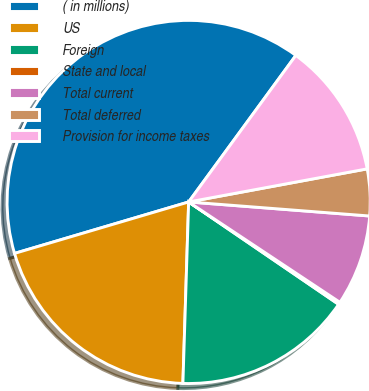Convert chart. <chart><loc_0><loc_0><loc_500><loc_500><pie_chart><fcel>( in millions)<fcel>US<fcel>Foreign<fcel>State and local<fcel>Total current<fcel>Total deferred<fcel>Provision for income taxes<nl><fcel>39.62%<fcel>19.92%<fcel>15.97%<fcel>0.21%<fcel>8.09%<fcel>4.15%<fcel>12.03%<nl></chart> 